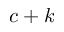<formula> <loc_0><loc_0><loc_500><loc_500>c + k</formula> 